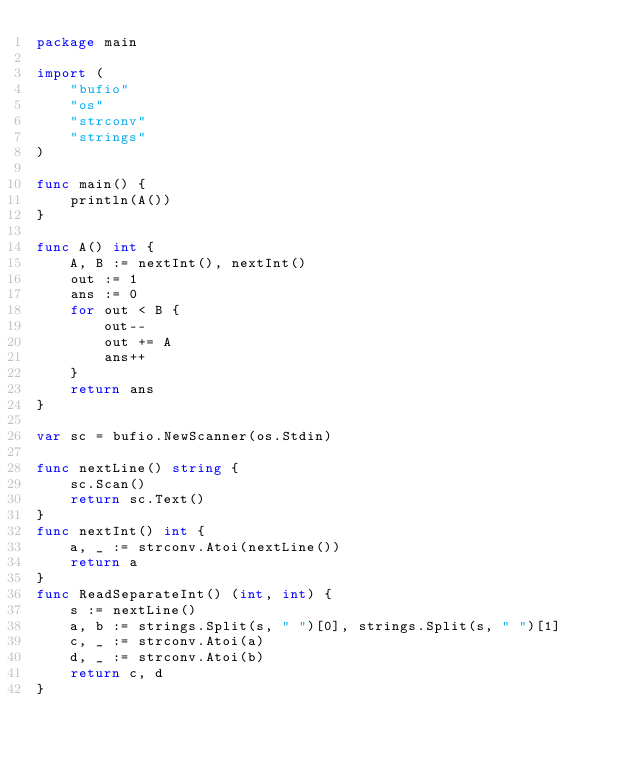<code> <loc_0><loc_0><loc_500><loc_500><_Go_>package main

import (
	"bufio"
	"os"
	"strconv"
	"strings"
)

func main() {
	println(A())
}

func A() int {
	A, B := nextInt(), nextInt()
	out := 1
	ans := 0
	for out < B {
		out--
		out += A
		ans++
	}
	return ans
}

var sc = bufio.NewScanner(os.Stdin)

func nextLine() string {
	sc.Scan()
	return sc.Text()
}
func nextInt() int {
	a, _ := strconv.Atoi(nextLine())
	return a
}
func ReadSeparateInt() (int, int) {
	s := nextLine()
	a, b := strings.Split(s, " ")[0], strings.Split(s, " ")[1]
	c, _ := strconv.Atoi(a)
	d, _ := strconv.Atoi(b)
	return c, d
}
</code> 